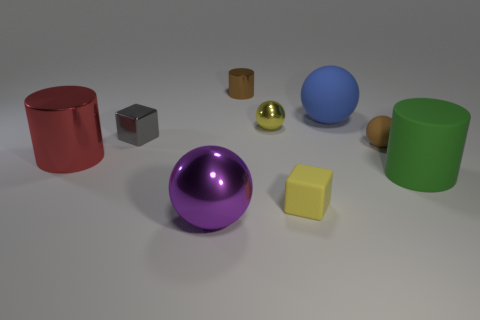Is the number of tiny yellow shiny objects that are in front of the large metal sphere less than the number of blocks that are in front of the brown cylinder?
Your answer should be compact. Yes. Do the brown cylinder and the blue thing have the same size?
Offer a terse response. No. What shape is the metal object that is both in front of the tiny metal block and on the right side of the tiny gray metal thing?
Keep it short and to the point. Sphere. How many small brown things are the same material as the large green thing?
Your response must be concise. 1. There is a tiny metal thing to the left of the purple ball; what number of tiny spheres are behind it?
Your answer should be very brief. 1. The large metallic object in front of the metallic cylinder that is in front of the large rubber object behind the big green cylinder is what shape?
Keep it short and to the point. Sphere. There is a thing that is the same color as the small cylinder; what size is it?
Offer a terse response. Small. How many things are either large red cylinders or tiny metal balls?
Ensure brevity in your answer.  2. What color is the shiny cylinder that is the same size as the metallic cube?
Give a very brief answer. Brown. Does the big purple object have the same shape as the big metallic thing behind the large metallic sphere?
Give a very brief answer. No. 